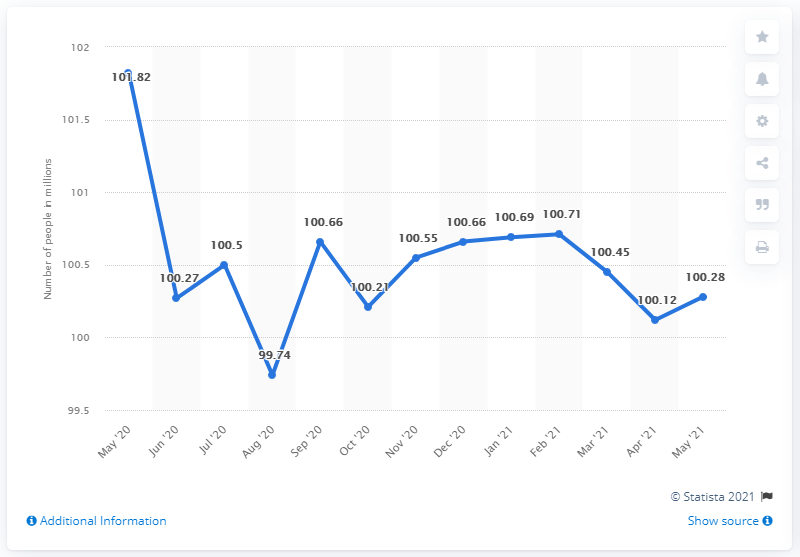How many people were in the inactive labor force in May 2021? In May 2021, the inactive labor force comprised approximately 100.28 million individuals. 